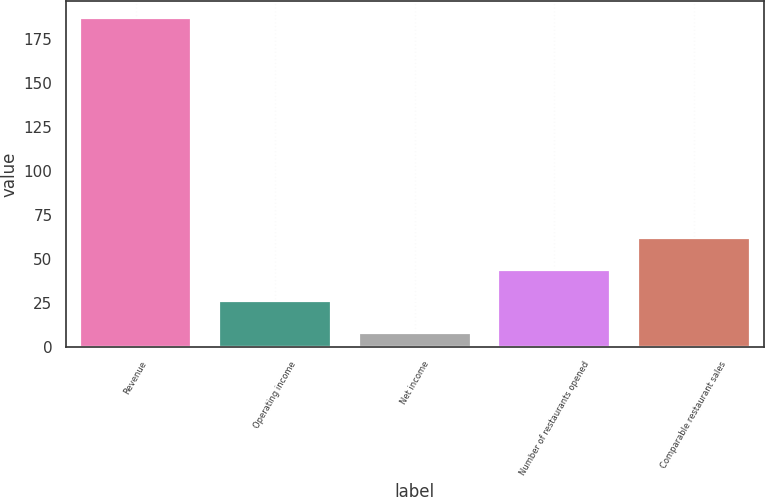Convert chart. <chart><loc_0><loc_0><loc_500><loc_500><bar_chart><fcel>Revenue<fcel>Operating income<fcel>Net income<fcel>Number of restaurants opened<fcel>Comparable restaurant sales<nl><fcel>187<fcel>25.9<fcel>8<fcel>43.8<fcel>61.7<nl></chart> 